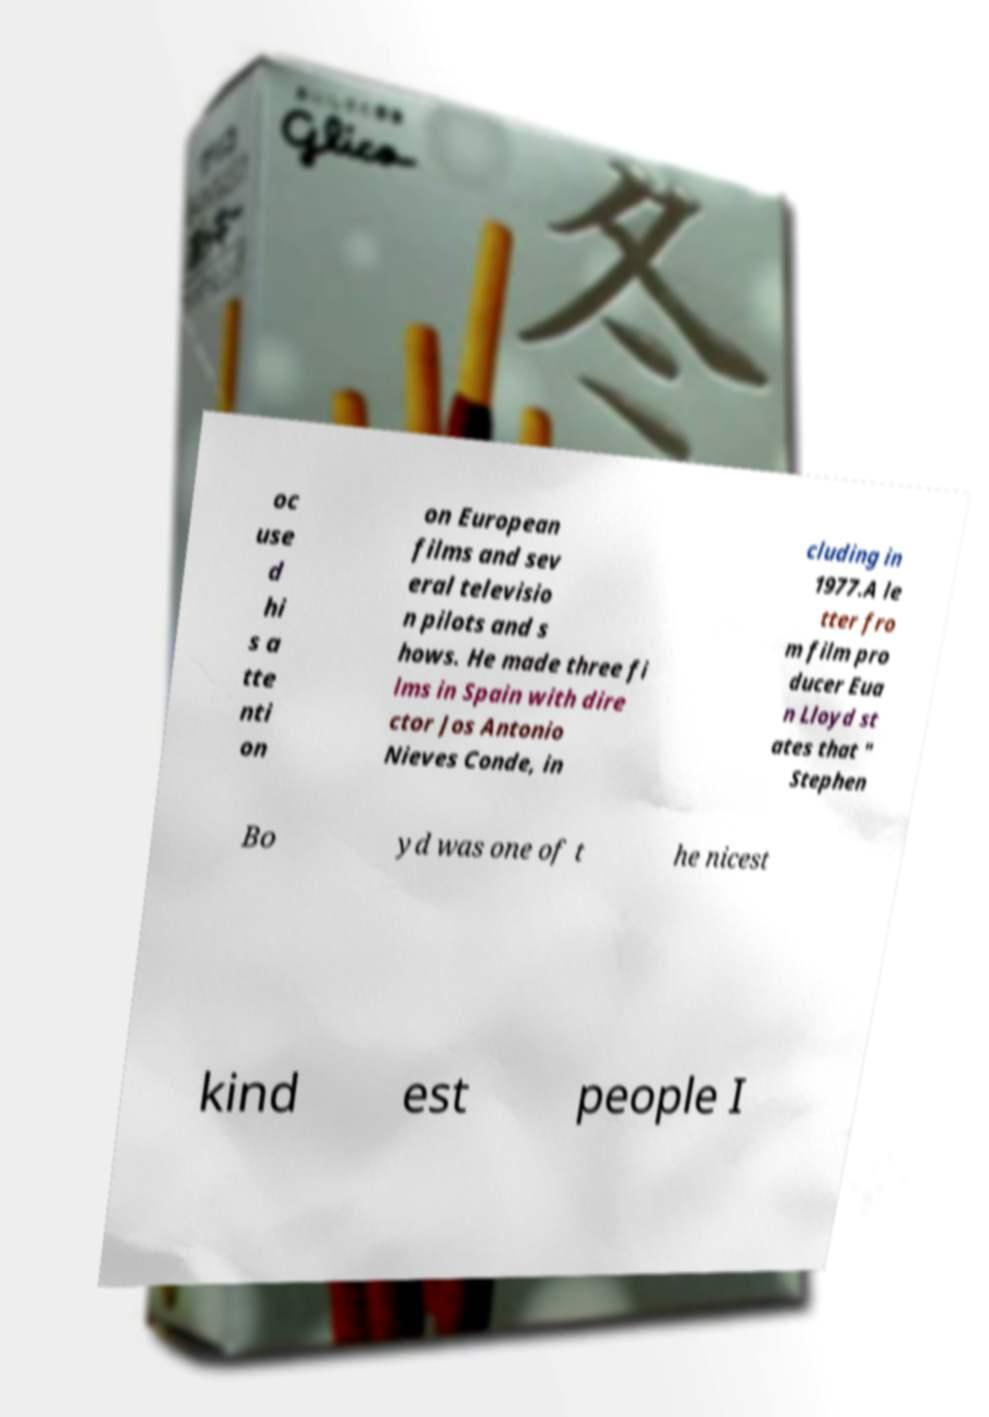Could you extract and type out the text from this image? oc use d hi s a tte nti on on European films and sev eral televisio n pilots and s hows. He made three fi lms in Spain with dire ctor Jos Antonio Nieves Conde, in cluding in 1977.A le tter fro m film pro ducer Eua n Lloyd st ates that " Stephen Bo yd was one of t he nicest kind est people I 